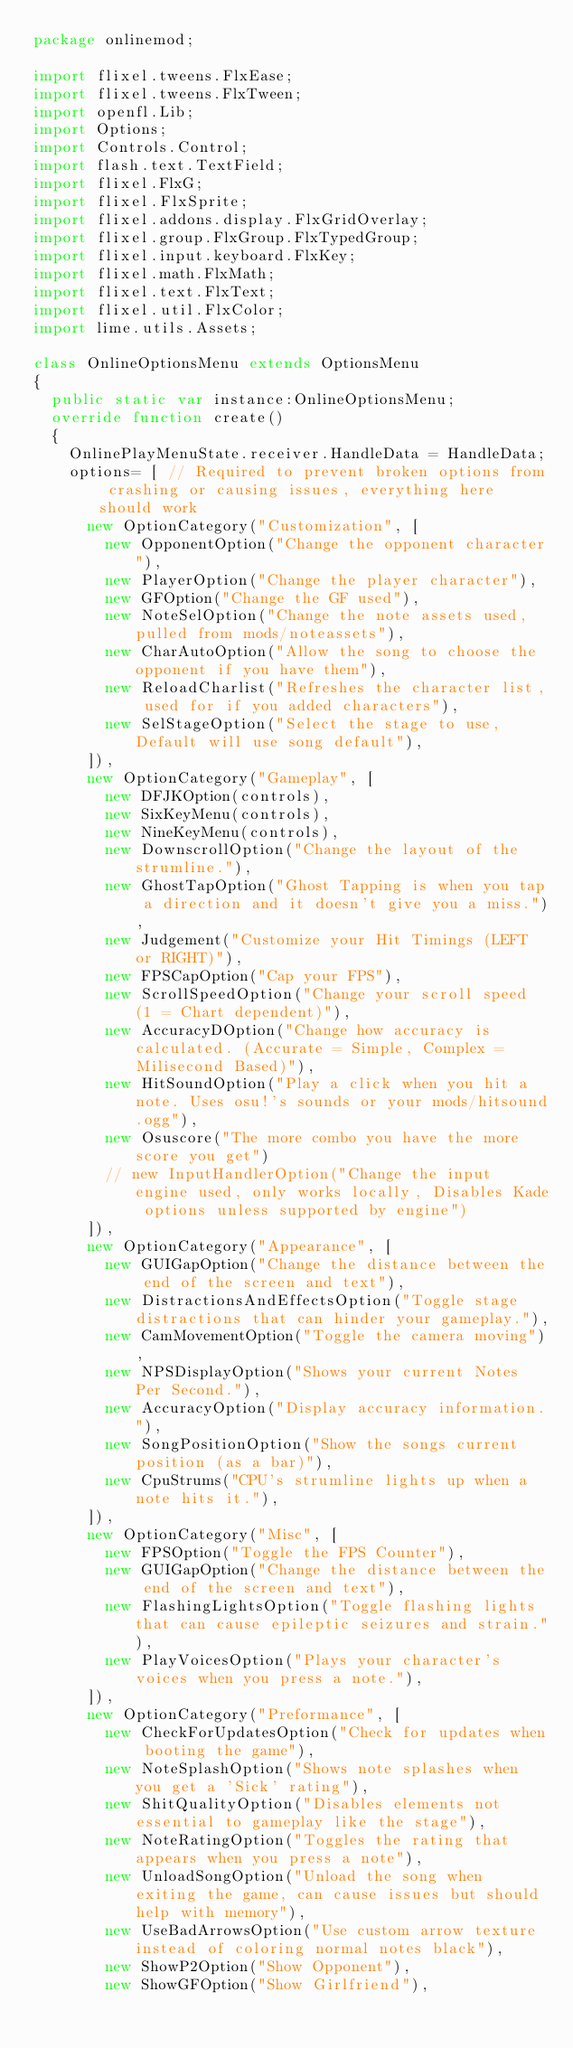Convert code to text. <code><loc_0><loc_0><loc_500><loc_500><_Haxe_>package onlinemod;

import flixel.tweens.FlxEase;
import flixel.tweens.FlxTween;
import openfl.Lib;
import Options;
import Controls.Control;
import flash.text.TextField;
import flixel.FlxG;
import flixel.FlxSprite;
import flixel.addons.display.FlxGridOverlay;
import flixel.group.FlxGroup.FlxTypedGroup;
import flixel.input.keyboard.FlxKey;
import flixel.math.FlxMath;
import flixel.text.FlxText;
import flixel.util.FlxColor;
import lime.utils.Assets;

class OnlineOptionsMenu extends OptionsMenu
{
	public static var instance:OnlineOptionsMenu;
	override function create()
	{
		OnlinePlayMenuState.receiver.HandleData = HandleData;
    options= [ // Required to prevent broken options from crashing or causing issues, everything here should work
      new OptionCategory("Customization", [
        new OpponentOption("Change the opponent character"),
        new PlayerOption("Change the player character"),
        new GFOption("Change the GF used"),
        new NoteSelOption("Change the note assets used, pulled from mods/noteassets"),
        new CharAutoOption("Allow the song to choose the opponent if you have them"),
        new ReloadCharlist("Refreshes the character list, used for if you added characters"),
        new SelStageOption("Select the stage to use, Default will use song default"),
      ]),
      new OptionCategory("Gameplay", [
        new DFJKOption(controls),
        new SixKeyMenu(controls),
        new NineKeyMenu(controls),
        new DownscrollOption("Change the layout of the strumline."),
        new GhostTapOption("Ghost Tapping is when you tap a direction and it doesn't give you a miss."),
        new Judgement("Customize your Hit Timings (LEFT or RIGHT)"),
        new FPSCapOption("Cap your FPS"),
        new ScrollSpeedOption("Change your scroll speed (1 = Chart dependent)"),
        new AccuracyDOption("Change how accuracy is calculated. (Accurate = Simple, Complex = Milisecond Based)"),
        new HitSoundOption("Play a click when you hit a note. Uses osu!'s sounds or your mods/hitsound.ogg"),
        new Osuscore("The more combo you have the more score you get")
        // new InputHandlerOption("Change the input engine used, only works locally, Disables Kade options unless supported by engine")
      ]),
      new OptionCategory("Appearance", [
        new GUIGapOption("Change the distance between the end of the screen and text"),
        new DistractionsAndEffectsOption("Toggle stage distractions that can hinder your gameplay."),
        new CamMovementOption("Toggle the camera moving"),
        new NPSDisplayOption("Shows your current Notes Per Second."),
        new AccuracyOption("Display accuracy information."),
        new SongPositionOption("Show the songs current position (as a bar)"),
        new CpuStrums("CPU's strumline lights up when a note hits it."),
      ]),
      new OptionCategory("Misc", [
        new FPSOption("Toggle the FPS Counter"),
        new GUIGapOption("Change the distance between the end of the screen and text"),
        new FlashingLightsOption("Toggle flashing lights that can cause epileptic seizures and strain."),
        new PlayVoicesOption("Plays your character's voices when you press a note."),
      ]),
      new OptionCategory("Preformance", [
        new CheckForUpdatesOption("Check for updates when booting the game"),
        new NoteSplashOption("Shows note splashes when you get a 'Sick' rating"),
        new ShitQualityOption("Disables elements not essential to gameplay like the stage"),
        new NoteRatingOption("Toggles the rating that appears when you press a note"),
        new UnloadSongOption("Unload the song when exiting the game, can cause issues but should help with memory"),
        new UseBadArrowsOption("Use custom arrow texture instead of coloring normal notes black"),
        new ShowP2Option("Show Opponent"),
        new ShowGFOption("Show Girlfriend"),</code> 